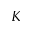<formula> <loc_0><loc_0><loc_500><loc_500>K</formula> 